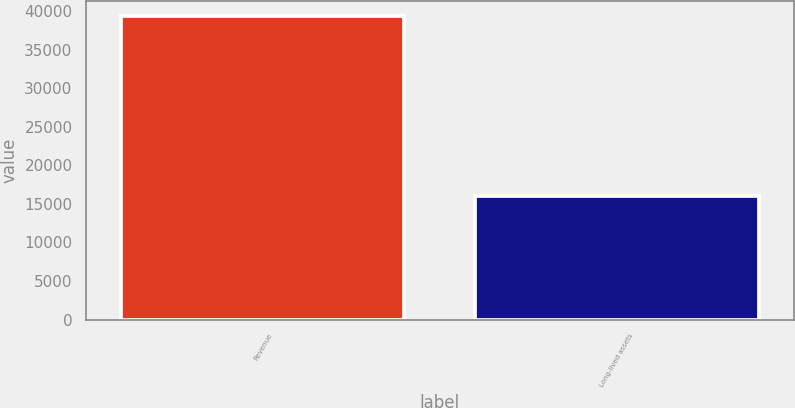Convert chart. <chart><loc_0><loc_0><loc_500><loc_500><bar_chart><fcel>Revenue<fcel>Long-lived assets<nl><fcel>39347<fcel>16085<nl></chart> 